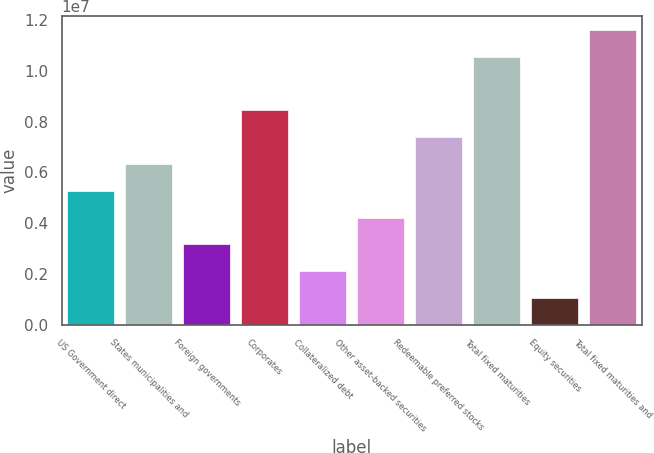<chart> <loc_0><loc_0><loc_500><loc_500><bar_chart><fcel>US Government direct<fcel>States municipalities and<fcel>Foreign governments<fcel>Corporates<fcel>Collateralized debt<fcel>Other asset-backed securities<fcel>Redeemable preferred stocks<fcel>Total fixed maturities<fcel>Equity securities<fcel>Total fixed maturities and<nl><fcel>5.28014e+06<fcel>6.33615e+06<fcel>3.16813e+06<fcel>8.44817e+06<fcel>2.11212e+06<fcel>4.22414e+06<fcel>7.39216e+06<fcel>1.0543e+07<fcel>1.05611e+06<fcel>1.1599e+07<nl></chart> 